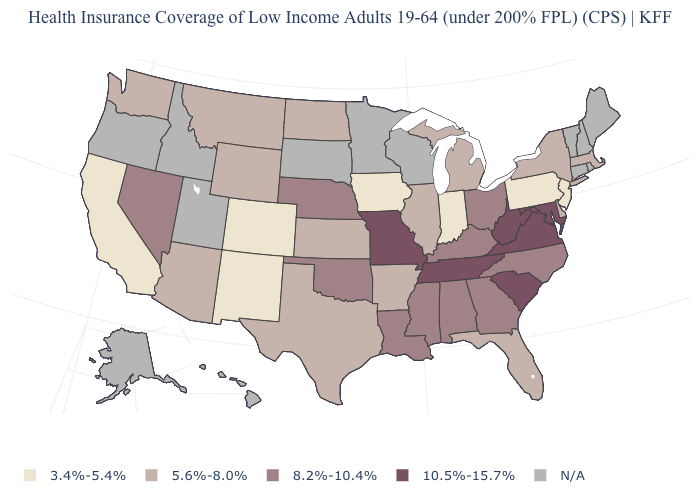What is the highest value in the Northeast ?
Concise answer only. 5.6%-8.0%. What is the value of Indiana?
Short answer required. 3.4%-5.4%. What is the value of Connecticut?
Quick response, please. N/A. Is the legend a continuous bar?
Short answer required. No. What is the value of New Mexico?
Write a very short answer. 3.4%-5.4%. Does South Carolina have the lowest value in the USA?
Quick response, please. No. Name the states that have a value in the range 10.5%-15.7%?
Answer briefly. Maryland, Missouri, South Carolina, Tennessee, Virginia, West Virginia. What is the highest value in the USA?
Answer briefly. 10.5%-15.7%. Among the states that border Massachusetts , which have the lowest value?
Give a very brief answer. New York. Name the states that have a value in the range 3.4%-5.4%?
Short answer required. California, Colorado, Indiana, Iowa, New Jersey, New Mexico, Pennsylvania. What is the value of New York?
Write a very short answer. 5.6%-8.0%. Does Indiana have the lowest value in the USA?
Short answer required. Yes. Name the states that have a value in the range 10.5%-15.7%?
Concise answer only. Maryland, Missouri, South Carolina, Tennessee, Virginia, West Virginia. Which states have the lowest value in the MidWest?
Answer briefly. Indiana, Iowa. 